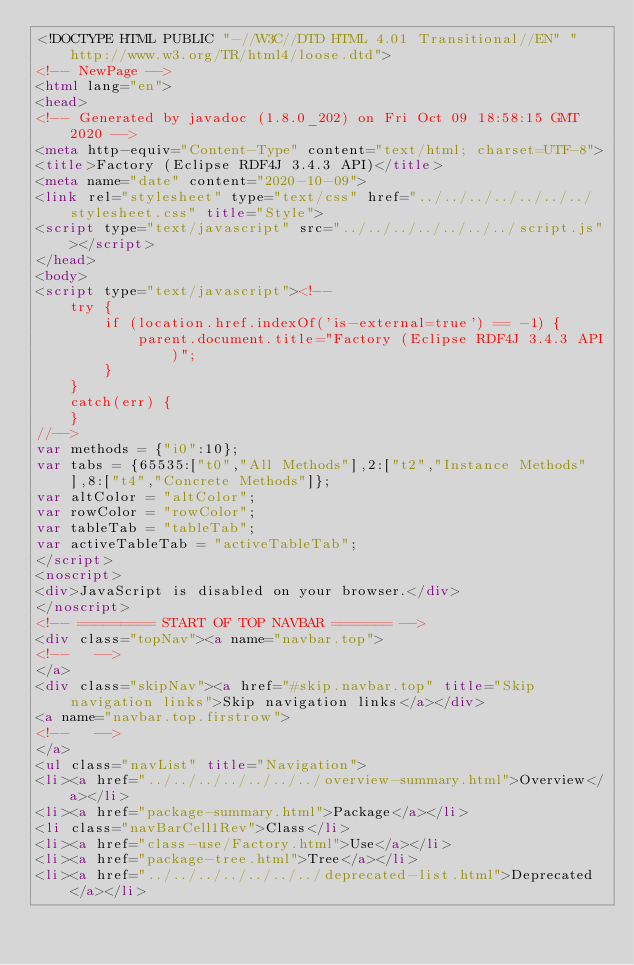<code> <loc_0><loc_0><loc_500><loc_500><_HTML_><!DOCTYPE HTML PUBLIC "-//W3C//DTD HTML 4.01 Transitional//EN" "http://www.w3.org/TR/html4/loose.dtd">
<!-- NewPage -->
<html lang="en">
<head>
<!-- Generated by javadoc (1.8.0_202) on Fri Oct 09 18:58:15 GMT 2020 -->
<meta http-equiv="Content-Type" content="text/html; charset=UTF-8">
<title>Factory (Eclipse RDF4J 3.4.3 API)</title>
<meta name="date" content="2020-10-09">
<link rel="stylesheet" type="text/css" href="../../../../../../../stylesheet.css" title="Style">
<script type="text/javascript" src="../../../../../../../script.js"></script>
</head>
<body>
<script type="text/javascript"><!--
    try {
        if (location.href.indexOf('is-external=true') == -1) {
            parent.document.title="Factory (Eclipse RDF4J 3.4.3 API)";
        }
    }
    catch(err) {
    }
//-->
var methods = {"i0":10};
var tabs = {65535:["t0","All Methods"],2:["t2","Instance Methods"],8:["t4","Concrete Methods"]};
var altColor = "altColor";
var rowColor = "rowColor";
var tableTab = "tableTab";
var activeTableTab = "activeTableTab";
</script>
<noscript>
<div>JavaScript is disabled on your browser.</div>
</noscript>
<!-- ========= START OF TOP NAVBAR ======= -->
<div class="topNav"><a name="navbar.top">
<!--   -->
</a>
<div class="skipNav"><a href="#skip.navbar.top" title="Skip navigation links">Skip navigation links</a></div>
<a name="navbar.top.firstrow">
<!--   -->
</a>
<ul class="navList" title="Navigation">
<li><a href="../../../../../../../overview-summary.html">Overview</a></li>
<li><a href="package-summary.html">Package</a></li>
<li class="navBarCell1Rev">Class</li>
<li><a href="class-use/Factory.html">Use</a></li>
<li><a href="package-tree.html">Tree</a></li>
<li><a href="../../../../../../../deprecated-list.html">Deprecated</a></li></code> 